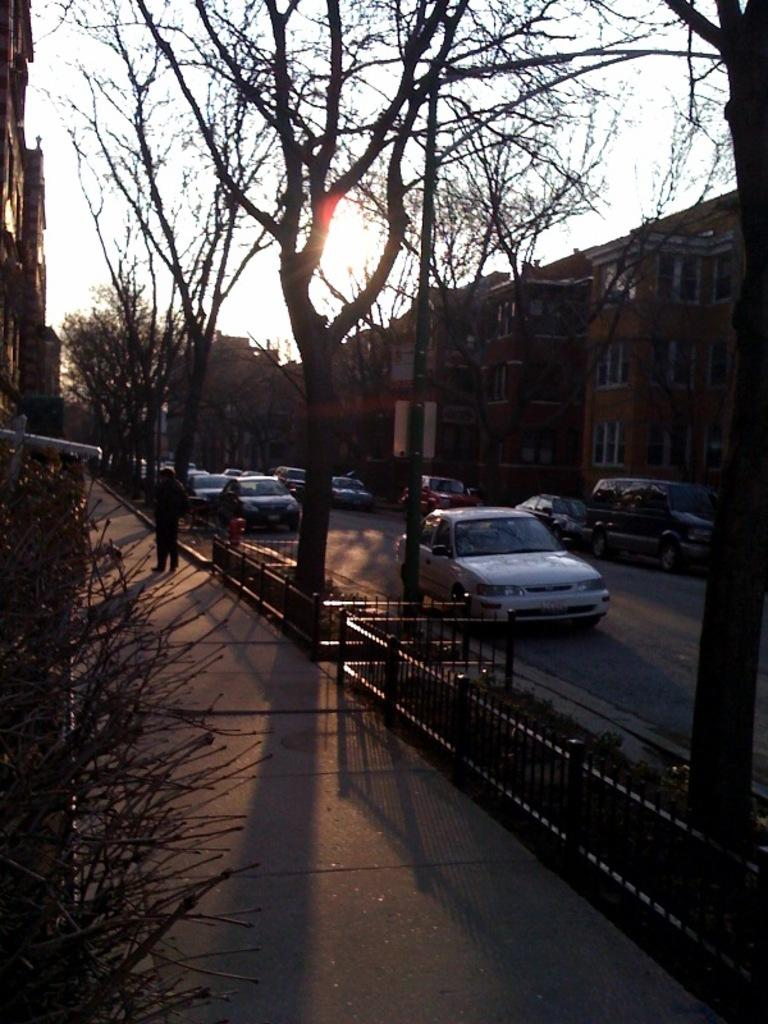What is located in the center of the image? There are trees in the center of the image. What else can be seen in the image besides the trees? There is a road in the image, and cars are present on the road. What is visible to the right side of the image? There are buildings to the right side of the image. How much profit do the giants make from the comb in the image? There are no giants or combs present in the image, so it is not possible to determine any profit made from a comb. 